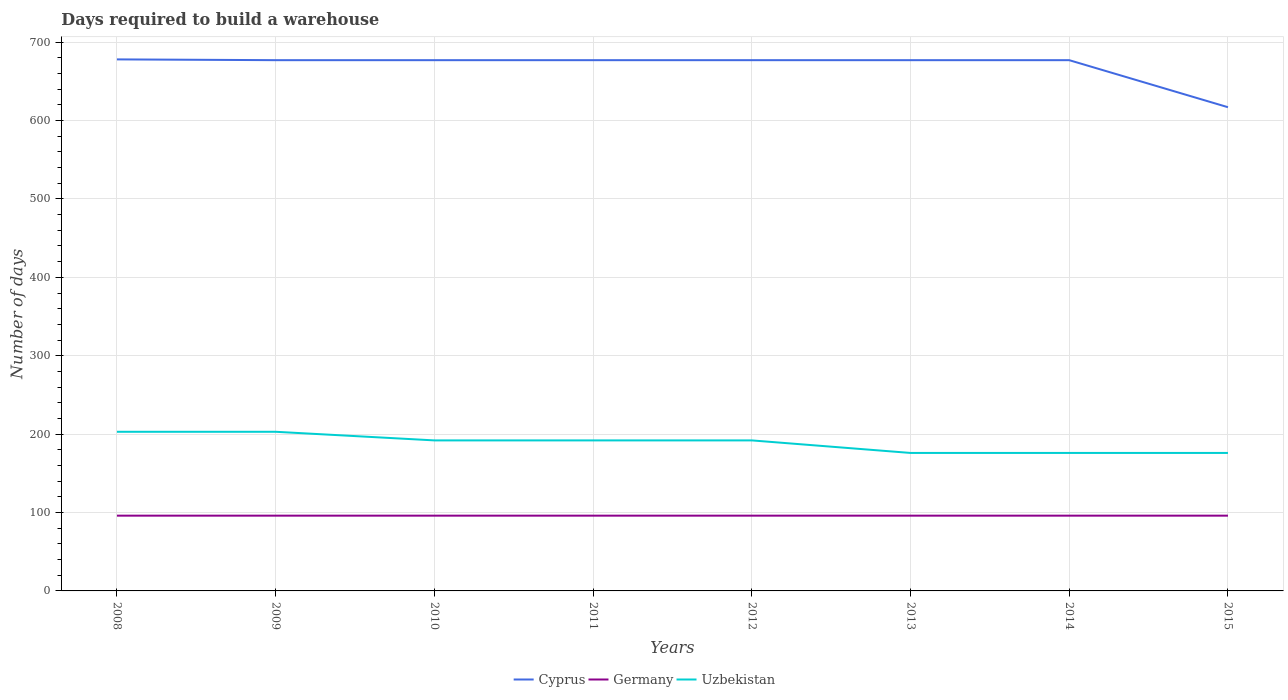How many different coloured lines are there?
Keep it short and to the point. 3. Does the line corresponding to Uzbekistan intersect with the line corresponding to Cyprus?
Keep it short and to the point. No. Across all years, what is the maximum days required to build a warehouse in in Cyprus?
Offer a terse response. 617. What is the difference between the highest and the second highest days required to build a warehouse in in Uzbekistan?
Provide a succinct answer. 27. What is the difference between the highest and the lowest days required to build a warehouse in in Uzbekistan?
Offer a terse response. 5. Where does the legend appear in the graph?
Provide a succinct answer. Bottom center. How many legend labels are there?
Provide a succinct answer. 3. What is the title of the graph?
Your answer should be very brief. Days required to build a warehouse. Does "Upper middle income" appear as one of the legend labels in the graph?
Your response must be concise. No. What is the label or title of the X-axis?
Offer a very short reply. Years. What is the label or title of the Y-axis?
Offer a terse response. Number of days. What is the Number of days in Cyprus in 2008?
Your answer should be very brief. 678. What is the Number of days in Germany in 2008?
Offer a terse response. 96. What is the Number of days in Uzbekistan in 2008?
Provide a succinct answer. 203. What is the Number of days in Cyprus in 2009?
Ensure brevity in your answer.  677. What is the Number of days in Germany in 2009?
Keep it short and to the point. 96. What is the Number of days of Uzbekistan in 2009?
Provide a succinct answer. 203. What is the Number of days in Cyprus in 2010?
Your answer should be very brief. 677. What is the Number of days in Germany in 2010?
Keep it short and to the point. 96. What is the Number of days in Uzbekistan in 2010?
Offer a terse response. 192. What is the Number of days of Cyprus in 2011?
Make the answer very short. 677. What is the Number of days in Germany in 2011?
Provide a short and direct response. 96. What is the Number of days in Uzbekistan in 2011?
Offer a very short reply. 192. What is the Number of days in Cyprus in 2012?
Offer a terse response. 677. What is the Number of days in Germany in 2012?
Your response must be concise. 96. What is the Number of days of Uzbekistan in 2012?
Provide a short and direct response. 192. What is the Number of days in Cyprus in 2013?
Offer a very short reply. 677. What is the Number of days of Germany in 2013?
Keep it short and to the point. 96. What is the Number of days of Uzbekistan in 2013?
Ensure brevity in your answer.  176. What is the Number of days of Cyprus in 2014?
Your answer should be compact. 677. What is the Number of days in Germany in 2014?
Make the answer very short. 96. What is the Number of days of Uzbekistan in 2014?
Keep it short and to the point. 176. What is the Number of days in Cyprus in 2015?
Provide a short and direct response. 617. What is the Number of days in Germany in 2015?
Ensure brevity in your answer.  96. What is the Number of days of Uzbekistan in 2015?
Keep it short and to the point. 176. Across all years, what is the maximum Number of days of Cyprus?
Give a very brief answer. 678. Across all years, what is the maximum Number of days in Germany?
Provide a succinct answer. 96. Across all years, what is the maximum Number of days of Uzbekistan?
Make the answer very short. 203. Across all years, what is the minimum Number of days of Cyprus?
Your answer should be compact. 617. Across all years, what is the minimum Number of days of Germany?
Provide a succinct answer. 96. Across all years, what is the minimum Number of days of Uzbekistan?
Provide a succinct answer. 176. What is the total Number of days in Cyprus in the graph?
Your answer should be compact. 5357. What is the total Number of days in Germany in the graph?
Offer a terse response. 768. What is the total Number of days in Uzbekistan in the graph?
Your response must be concise. 1510. What is the difference between the Number of days in Uzbekistan in 2008 and that in 2009?
Your answer should be very brief. 0. What is the difference between the Number of days of Germany in 2008 and that in 2010?
Provide a short and direct response. 0. What is the difference between the Number of days of Uzbekistan in 2008 and that in 2010?
Keep it short and to the point. 11. What is the difference between the Number of days of Germany in 2008 and that in 2011?
Your answer should be very brief. 0. What is the difference between the Number of days of Uzbekistan in 2008 and that in 2011?
Give a very brief answer. 11. What is the difference between the Number of days in Uzbekistan in 2008 and that in 2012?
Ensure brevity in your answer.  11. What is the difference between the Number of days of Cyprus in 2008 and that in 2014?
Make the answer very short. 1. What is the difference between the Number of days in Germany in 2008 and that in 2014?
Your answer should be compact. 0. What is the difference between the Number of days in Uzbekistan in 2008 and that in 2014?
Give a very brief answer. 27. What is the difference between the Number of days of Germany in 2008 and that in 2015?
Your response must be concise. 0. What is the difference between the Number of days in Cyprus in 2009 and that in 2010?
Provide a short and direct response. 0. What is the difference between the Number of days in Uzbekistan in 2009 and that in 2010?
Your response must be concise. 11. What is the difference between the Number of days in Uzbekistan in 2009 and that in 2011?
Your answer should be very brief. 11. What is the difference between the Number of days of Cyprus in 2009 and that in 2012?
Provide a succinct answer. 0. What is the difference between the Number of days of Cyprus in 2009 and that in 2013?
Keep it short and to the point. 0. What is the difference between the Number of days of Uzbekistan in 2009 and that in 2013?
Offer a very short reply. 27. What is the difference between the Number of days in Germany in 2010 and that in 2011?
Offer a very short reply. 0. What is the difference between the Number of days of Uzbekistan in 2010 and that in 2011?
Give a very brief answer. 0. What is the difference between the Number of days of Cyprus in 2010 and that in 2012?
Provide a short and direct response. 0. What is the difference between the Number of days of Uzbekistan in 2010 and that in 2012?
Make the answer very short. 0. What is the difference between the Number of days of Uzbekistan in 2010 and that in 2014?
Offer a very short reply. 16. What is the difference between the Number of days in Uzbekistan in 2010 and that in 2015?
Offer a terse response. 16. What is the difference between the Number of days of Germany in 2011 and that in 2012?
Your answer should be compact. 0. What is the difference between the Number of days in Uzbekistan in 2011 and that in 2012?
Your response must be concise. 0. What is the difference between the Number of days in Uzbekistan in 2011 and that in 2013?
Give a very brief answer. 16. What is the difference between the Number of days in Germany in 2011 and that in 2014?
Make the answer very short. 0. What is the difference between the Number of days of Cyprus in 2011 and that in 2015?
Offer a very short reply. 60. What is the difference between the Number of days in Cyprus in 2012 and that in 2014?
Make the answer very short. 0. What is the difference between the Number of days in Uzbekistan in 2012 and that in 2014?
Make the answer very short. 16. What is the difference between the Number of days in Cyprus in 2012 and that in 2015?
Provide a succinct answer. 60. What is the difference between the Number of days of Germany in 2012 and that in 2015?
Your answer should be compact. 0. What is the difference between the Number of days in Cyprus in 2013 and that in 2014?
Provide a short and direct response. 0. What is the difference between the Number of days of Cyprus in 2013 and that in 2015?
Give a very brief answer. 60. What is the difference between the Number of days of Uzbekistan in 2013 and that in 2015?
Ensure brevity in your answer.  0. What is the difference between the Number of days of Cyprus in 2014 and that in 2015?
Provide a short and direct response. 60. What is the difference between the Number of days of Cyprus in 2008 and the Number of days of Germany in 2009?
Offer a very short reply. 582. What is the difference between the Number of days of Cyprus in 2008 and the Number of days of Uzbekistan in 2009?
Your answer should be very brief. 475. What is the difference between the Number of days of Germany in 2008 and the Number of days of Uzbekistan in 2009?
Give a very brief answer. -107. What is the difference between the Number of days in Cyprus in 2008 and the Number of days in Germany in 2010?
Offer a terse response. 582. What is the difference between the Number of days in Cyprus in 2008 and the Number of days in Uzbekistan in 2010?
Your answer should be very brief. 486. What is the difference between the Number of days in Germany in 2008 and the Number of days in Uzbekistan in 2010?
Provide a succinct answer. -96. What is the difference between the Number of days in Cyprus in 2008 and the Number of days in Germany in 2011?
Provide a succinct answer. 582. What is the difference between the Number of days in Cyprus in 2008 and the Number of days in Uzbekistan in 2011?
Offer a terse response. 486. What is the difference between the Number of days of Germany in 2008 and the Number of days of Uzbekistan in 2011?
Your answer should be compact. -96. What is the difference between the Number of days of Cyprus in 2008 and the Number of days of Germany in 2012?
Ensure brevity in your answer.  582. What is the difference between the Number of days in Cyprus in 2008 and the Number of days in Uzbekistan in 2012?
Offer a very short reply. 486. What is the difference between the Number of days of Germany in 2008 and the Number of days of Uzbekistan in 2012?
Your response must be concise. -96. What is the difference between the Number of days in Cyprus in 2008 and the Number of days in Germany in 2013?
Your answer should be very brief. 582. What is the difference between the Number of days in Cyprus in 2008 and the Number of days in Uzbekistan in 2013?
Your answer should be compact. 502. What is the difference between the Number of days in Germany in 2008 and the Number of days in Uzbekistan in 2013?
Your answer should be compact. -80. What is the difference between the Number of days in Cyprus in 2008 and the Number of days in Germany in 2014?
Give a very brief answer. 582. What is the difference between the Number of days of Cyprus in 2008 and the Number of days of Uzbekistan in 2014?
Your response must be concise. 502. What is the difference between the Number of days of Germany in 2008 and the Number of days of Uzbekistan in 2014?
Ensure brevity in your answer.  -80. What is the difference between the Number of days in Cyprus in 2008 and the Number of days in Germany in 2015?
Your answer should be very brief. 582. What is the difference between the Number of days in Cyprus in 2008 and the Number of days in Uzbekistan in 2015?
Keep it short and to the point. 502. What is the difference between the Number of days of Germany in 2008 and the Number of days of Uzbekistan in 2015?
Ensure brevity in your answer.  -80. What is the difference between the Number of days in Cyprus in 2009 and the Number of days in Germany in 2010?
Make the answer very short. 581. What is the difference between the Number of days in Cyprus in 2009 and the Number of days in Uzbekistan in 2010?
Provide a short and direct response. 485. What is the difference between the Number of days of Germany in 2009 and the Number of days of Uzbekistan in 2010?
Your answer should be compact. -96. What is the difference between the Number of days in Cyprus in 2009 and the Number of days in Germany in 2011?
Your answer should be compact. 581. What is the difference between the Number of days of Cyprus in 2009 and the Number of days of Uzbekistan in 2011?
Provide a short and direct response. 485. What is the difference between the Number of days in Germany in 2009 and the Number of days in Uzbekistan in 2011?
Provide a short and direct response. -96. What is the difference between the Number of days of Cyprus in 2009 and the Number of days of Germany in 2012?
Provide a short and direct response. 581. What is the difference between the Number of days of Cyprus in 2009 and the Number of days of Uzbekistan in 2012?
Your answer should be very brief. 485. What is the difference between the Number of days in Germany in 2009 and the Number of days in Uzbekistan in 2012?
Offer a terse response. -96. What is the difference between the Number of days of Cyprus in 2009 and the Number of days of Germany in 2013?
Offer a very short reply. 581. What is the difference between the Number of days of Cyprus in 2009 and the Number of days of Uzbekistan in 2013?
Your answer should be very brief. 501. What is the difference between the Number of days of Germany in 2009 and the Number of days of Uzbekistan in 2013?
Provide a short and direct response. -80. What is the difference between the Number of days of Cyprus in 2009 and the Number of days of Germany in 2014?
Provide a short and direct response. 581. What is the difference between the Number of days in Cyprus in 2009 and the Number of days in Uzbekistan in 2014?
Provide a succinct answer. 501. What is the difference between the Number of days in Germany in 2009 and the Number of days in Uzbekistan in 2014?
Your response must be concise. -80. What is the difference between the Number of days of Cyprus in 2009 and the Number of days of Germany in 2015?
Your response must be concise. 581. What is the difference between the Number of days of Cyprus in 2009 and the Number of days of Uzbekistan in 2015?
Offer a very short reply. 501. What is the difference between the Number of days of Germany in 2009 and the Number of days of Uzbekistan in 2015?
Ensure brevity in your answer.  -80. What is the difference between the Number of days of Cyprus in 2010 and the Number of days of Germany in 2011?
Keep it short and to the point. 581. What is the difference between the Number of days in Cyprus in 2010 and the Number of days in Uzbekistan in 2011?
Your response must be concise. 485. What is the difference between the Number of days of Germany in 2010 and the Number of days of Uzbekistan in 2011?
Your answer should be compact. -96. What is the difference between the Number of days in Cyprus in 2010 and the Number of days in Germany in 2012?
Your answer should be compact. 581. What is the difference between the Number of days in Cyprus in 2010 and the Number of days in Uzbekistan in 2012?
Offer a very short reply. 485. What is the difference between the Number of days of Germany in 2010 and the Number of days of Uzbekistan in 2012?
Keep it short and to the point. -96. What is the difference between the Number of days of Cyprus in 2010 and the Number of days of Germany in 2013?
Ensure brevity in your answer.  581. What is the difference between the Number of days of Cyprus in 2010 and the Number of days of Uzbekistan in 2013?
Ensure brevity in your answer.  501. What is the difference between the Number of days of Germany in 2010 and the Number of days of Uzbekistan in 2013?
Give a very brief answer. -80. What is the difference between the Number of days in Cyprus in 2010 and the Number of days in Germany in 2014?
Make the answer very short. 581. What is the difference between the Number of days of Cyprus in 2010 and the Number of days of Uzbekistan in 2014?
Your response must be concise. 501. What is the difference between the Number of days of Germany in 2010 and the Number of days of Uzbekistan in 2014?
Your response must be concise. -80. What is the difference between the Number of days of Cyprus in 2010 and the Number of days of Germany in 2015?
Keep it short and to the point. 581. What is the difference between the Number of days in Cyprus in 2010 and the Number of days in Uzbekistan in 2015?
Your answer should be very brief. 501. What is the difference between the Number of days in Germany in 2010 and the Number of days in Uzbekistan in 2015?
Provide a short and direct response. -80. What is the difference between the Number of days of Cyprus in 2011 and the Number of days of Germany in 2012?
Offer a very short reply. 581. What is the difference between the Number of days in Cyprus in 2011 and the Number of days in Uzbekistan in 2012?
Make the answer very short. 485. What is the difference between the Number of days in Germany in 2011 and the Number of days in Uzbekistan in 2012?
Your answer should be very brief. -96. What is the difference between the Number of days in Cyprus in 2011 and the Number of days in Germany in 2013?
Offer a very short reply. 581. What is the difference between the Number of days of Cyprus in 2011 and the Number of days of Uzbekistan in 2013?
Make the answer very short. 501. What is the difference between the Number of days of Germany in 2011 and the Number of days of Uzbekistan in 2013?
Make the answer very short. -80. What is the difference between the Number of days of Cyprus in 2011 and the Number of days of Germany in 2014?
Offer a terse response. 581. What is the difference between the Number of days in Cyprus in 2011 and the Number of days in Uzbekistan in 2014?
Your answer should be compact. 501. What is the difference between the Number of days of Germany in 2011 and the Number of days of Uzbekistan in 2014?
Your answer should be very brief. -80. What is the difference between the Number of days in Cyprus in 2011 and the Number of days in Germany in 2015?
Provide a short and direct response. 581. What is the difference between the Number of days of Cyprus in 2011 and the Number of days of Uzbekistan in 2015?
Make the answer very short. 501. What is the difference between the Number of days of Germany in 2011 and the Number of days of Uzbekistan in 2015?
Offer a very short reply. -80. What is the difference between the Number of days in Cyprus in 2012 and the Number of days in Germany in 2013?
Offer a terse response. 581. What is the difference between the Number of days of Cyprus in 2012 and the Number of days of Uzbekistan in 2013?
Make the answer very short. 501. What is the difference between the Number of days of Germany in 2012 and the Number of days of Uzbekistan in 2013?
Offer a very short reply. -80. What is the difference between the Number of days of Cyprus in 2012 and the Number of days of Germany in 2014?
Your response must be concise. 581. What is the difference between the Number of days in Cyprus in 2012 and the Number of days in Uzbekistan in 2014?
Provide a succinct answer. 501. What is the difference between the Number of days in Germany in 2012 and the Number of days in Uzbekistan in 2014?
Provide a short and direct response. -80. What is the difference between the Number of days of Cyprus in 2012 and the Number of days of Germany in 2015?
Keep it short and to the point. 581. What is the difference between the Number of days in Cyprus in 2012 and the Number of days in Uzbekistan in 2015?
Offer a very short reply. 501. What is the difference between the Number of days of Germany in 2012 and the Number of days of Uzbekistan in 2015?
Make the answer very short. -80. What is the difference between the Number of days of Cyprus in 2013 and the Number of days of Germany in 2014?
Make the answer very short. 581. What is the difference between the Number of days in Cyprus in 2013 and the Number of days in Uzbekistan in 2014?
Provide a short and direct response. 501. What is the difference between the Number of days of Germany in 2013 and the Number of days of Uzbekistan in 2014?
Your response must be concise. -80. What is the difference between the Number of days of Cyprus in 2013 and the Number of days of Germany in 2015?
Make the answer very short. 581. What is the difference between the Number of days in Cyprus in 2013 and the Number of days in Uzbekistan in 2015?
Your response must be concise. 501. What is the difference between the Number of days of Germany in 2013 and the Number of days of Uzbekistan in 2015?
Offer a very short reply. -80. What is the difference between the Number of days of Cyprus in 2014 and the Number of days of Germany in 2015?
Keep it short and to the point. 581. What is the difference between the Number of days in Cyprus in 2014 and the Number of days in Uzbekistan in 2015?
Offer a terse response. 501. What is the difference between the Number of days of Germany in 2014 and the Number of days of Uzbekistan in 2015?
Your answer should be compact. -80. What is the average Number of days of Cyprus per year?
Ensure brevity in your answer.  669.62. What is the average Number of days in Germany per year?
Your answer should be compact. 96. What is the average Number of days of Uzbekistan per year?
Make the answer very short. 188.75. In the year 2008, what is the difference between the Number of days of Cyprus and Number of days of Germany?
Provide a short and direct response. 582. In the year 2008, what is the difference between the Number of days of Cyprus and Number of days of Uzbekistan?
Keep it short and to the point. 475. In the year 2008, what is the difference between the Number of days in Germany and Number of days in Uzbekistan?
Provide a short and direct response. -107. In the year 2009, what is the difference between the Number of days in Cyprus and Number of days in Germany?
Your answer should be very brief. 581. In the year 2009, what is the difference between the Number of days in Cyprus and Number of days in Uzbekistan?
Make the answer very short. 474. In the year 2009, what is the difference between the Number of days of Germany and Number of days of Uzbekistan?
Provide a succinct answer. -107. In the year 2010, what is the difference between the Number of days of Cyprus and Number of days of Germany?
Provide a succinct answer. 581. In the year 2010, what is the difference between the Number of days in Cyprus and Number of days in Uzbekistan?
Give a very brief answer. 485. In the year 2010, what is the difference between the Number of days of Germany and Number of days of Uzbekistan?
Keep it short and to the point. -96. In the year 2011, what is the difference between the Number of days of Cyprus and Number of days of Germany?
Keep it short and to the point. 581. In the year 2011, what is the difference between the Number of days of Cyprus and Number of days of Uzbekistan?
Your response must be concise. 485. In the year 2011, what is the difference between the Number of days in Germany and Number of days in Uzbekistan?
Your answer should be very brief. -96. In the year 2012, what is the difference between the Number of days in Cyprus and Number of days in Germany?
Keep it short and to the point. 581. In the year 2012, what is the difference between the Number of days of Cyprus and Number of days of Uzbekistan?
Offer a very short reply. 485. In the year 2012, what is the difference between the Number of days of Germany and Number of days of Uzbekistan?
Your response must be concise. -96. In the year 2013, what is the difference between the Number of days in Cyprus and Number of days in Germany?
Your answer should be compact. 581. In the year 2013, what is the difference between the Number of days of Cyprus and Number of days of Uzbekistan?
Provide a succinct answer. 501. In the year 2013, what is the difference between the Number of days of Germany and Number of days of Uzbekistan?
Ensure brevity in your answer.  -80. In the year 2014, what is the difference between the Number of days of Cyprus and Number of days of Germany?
Provide a short and direct response. 581. In the year 2014, what is the difference between the Number of days in Cyprus and Number of days in Uzbekistan?
Provide a short and direct response. 501. In the year 2014, what is the difference between the Number of days in Germany and Number of days in Uzbekistan?
Your answer should be very brief. -80. In the year 2015, what is the difference between the Number of days of Cyprus and Number of days of Germany?
Your answer should be very brief. 521. In the year 2015, what is the difference between the Number of days in Cyprus and Number of days in Uzbekistan?
Offer a terse response. 441. In the year 2015, what is the difference between the Number of days of Germany and Number of days of Uzbekistan?
Ensure brevity in your answer.  -80. What is the ratio of the Number of days in Germany in 2008 to that in 2009?
Give a very brief answer. 1. What is the ratio of the Number of days in Uzbekistan in 2008 to that in 2010?
Provide a succinct answer. 1.06. What is the ratio of the Number of days of Uzbekistan in 2008 to that in 2011?
Ensure brevity in your answer.  1.06. What is the ratio of the Number of days in Uzbekistan in 2008 to that in 2012?
Ensure brevity in your answer.  1.06. What is the ratio of the Number of days of Cyprus in 2008 to that in 2013?
Provide a succinct answer. 1. What is the ratio of the Number of days of Germany in 2008 to that in 2013?
Give a very brief answer. 1. What is the ratio of the Number of days of Uzbekistan in 2008 to that in 2013?
Keep it short and to the point. 1.15. What is the ratio of the Number of days in Uzbekistan in 2008 to that in 2014?
Make the answer very short. 1.15. What is the ratio of the Number of days of Cyprus in 2008 to that in 2015?
Your answer should be compact. 1.1. What is the ratio of the Number of days of Germany in 2008 to that in 2015?
Provide a succinct answer. 1. What is the ratio of the Number of days in Uzbekistan in 2008 to that in 2015?
Offer a very short reply. 1.15. What is the ratio of the Number of days in Germany in 2009 to that in 2010?
Your response must be concise. 1. What is the ratio of the Number of days in Uzbekistan in 2009 to that in 2010?
Make the answer very short. 1.06. What is the ratio of the Number of days in Germany in 2009 to that in 2011?
Ensure brevity in your answer.  1. What is the ratio of the Number of days of Uzbekistan in 2009 to that in 2011?
Your answer should be compact. 1.06. What is the ratio of the Number of days of Cyprus in 2009 to that in 2012?
Offer a very short reply. 1. What is the ratio of the Number of days in Germany in 2009 to that in 2012?
Give a very brief answer. 1. What is the ratio of the Number of days in Uzbekistan in 2009 to that in 2012?
Offer a terse response. 1.06. What is the ratio of the Number of days of Cyprus in 2009 to that in 2013?
Your answer should be compact. 1. What is the ratio of the Number of days of Germany in 2009 to that in 2013?
Give a very brief answer. 1. What is the ratio of the Number of days of Uzbekistan in 2009 to that in 2013?
Offer a terse response. 1.15. What is the ratio of the Number of days of Uzbekistan in 2009 to that in 2014?
Keep it short and to the point. 1.15. What is the ratio of the Number of days of Cyprus in 2009 to that in 2015?
Your answer should be very brief. 1.1. What is the ratio of the Number of days of Germany in 2009 to that in 2015?
Offer a very short reply. 1. What is the ratio of the Number of days in Uzbekistan in 2009 to that in 2015?
Keep it short and to the point. 1.15. What is the ratio of the Number of days in Germany in 2010 to that in 2012?
Your answer should be very brief. 1. What is the ratio of the Number of days in Cyprus in 2010 to that in 2013?
Offer a terse response. 1. What is the ratio of the Number of days in Cyprus in 2010 to that in 2014?
Provide a short and direct response. 1. What is the ratio of the Number of days of Germany in 2010 to that in 2014?
Offer a terse response. 1. What is the ratio of the Number of days in Uzbekistan in 2010 to that in 2014?
Give a very brief answer. 1.09. What is the ratio of the Number of days of Cyprus in 2010 to that in 2015?
Your answer should be very brief. 1.1. What is the ratio of the Number of days in Germany in 2010 to that in 2015?
Make the answer very short. 1. What is the ratio of the Number of days in Uzbekistan in 2010 to that in 2015?
Your answer should be compact. 1.09. What is the ratio of the Number of days in Cyprus in 2011 to that in 2012?
Offer a terse response. 1. What is the ratio of the Number of days in Germany in 2011 to that in 2012?
Provide a succinct answer. 1. What is the ratio of the Number of days of Uzbekistan in 2011 to that in 2012?
Provide a succinct answer. 1. What is the ratio of the Number of days of Cyprus in 2011 to that in 2013?
Provide a succinct answer. 1. What is the ratio of the Number of days of Uzbekistan in 2011 to that in 2014?
Your answer should be compact. 1.09. What is the ratio of the Number of days in Cyprus in 2011 to that in 2015?
Provide a short and direct response. 1.1. What is the ratio of the Number of days of Germany in 2011 to that in 2015?
Provide a succinct answer. 1. What is the ratio of the Number of days of Uzbekistan in 2011 to that in 2015?
Offer a very short reply. 1.09. What is the ratio of the Number of days of Cyprus in 2012 to that in 2013?
Your answer should be very brief. 1. What is the ratio of the Number of days in Germany in 2012 to that in 2013?
Make the answer very short. 1. What is the ratio of the Number of days of Uzbekistan in 2012 to that in 2013?
Your answer should be very brief. 1.09. What is the ratio of the Number of days in Cyprus in 2012 to that in 2014?
Offer a terse response. 1. What is the ratio of the Number of days of Cyprus in 2012 to that in 2015?
Offer a terse response. 1.1. What is the ratio of the Number of days in Germany in 2012 to that in 2015?
Offer a terse response. 1. What is the ratio of the Number of days in Uzbekistan in 2013 to that in 2014?
Provide a succinct answer. 1. What is the ratio of the Number of days of Cyprus in 2013 to that in 2015?
Provide a short and direct response. 1.1. What is the ratio of the Number of days of Uzbekistan in 2013 to that in 2015?
Your answer should be very brief. 1. What is the ratio of the Number of days of Cyprus in 2014 to that in 2015?
Offer a very short reply. 1.1. What is the difference between the highest and the second highest Number of days of Germany?
Ensure brevity in your answer.  0. What is the difference between the highest and the second highest Number of days of Uzbekistan?
Your answer should be compact. 0. 